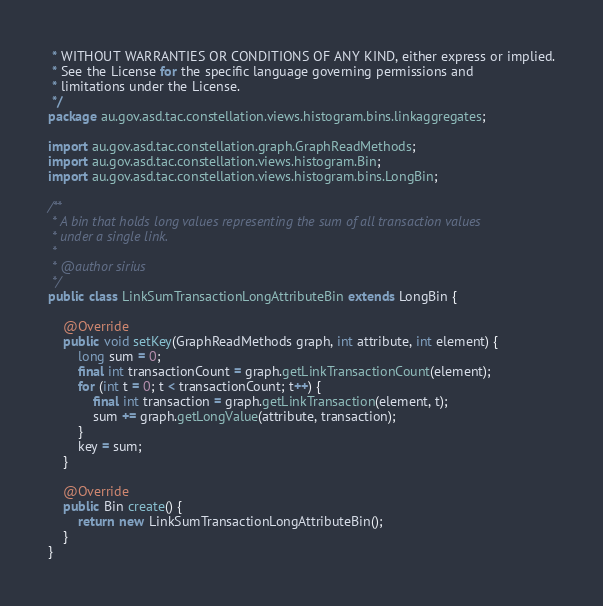<code> <loc_0><loc_0><loc_500><loc_500><_Java_> * WITHOUT WARRANTIES OR CONDITIONS OF ANY KIND, either express or implied.
 * See the License for the specific language governing permissions and
 * limitations under the License.
 */
package au.gov.asd.tac.constellation.views.histogram.bins.linkaggregates;

import au.gov.asd.tac.constellation.graph.GraphReadMethods;
import au.gov.asd.tac.constellation.views.histogram.Bin;
import au.gov.asd.tac.constellation.views.histogram.bins.LongBin;

/**
 * A bin that holds long values representing the sum of all transaction values
 * under a single link.
 *
 * @author sirius
 */
public class LinkSumTransactionLongAttributeBin extends LongBin {

    @Override
    public void setKey(GraphReadMethods graph, int attribute, int element) {
        long sum = 0;
        final int transactionCount = graph.getLinkTransactionCount(element);
        for (int t = 0; t < transactionCount; t++) {
            final int transaction = graph.getLinkTransaction(element, t);
            sum += graph.getLongValue(attribute, transaction);
        }
        key = sum;
    }

    @Override
    public Bin create() {
        return new LinkSumTransactionLongAttributeBin();
    }
}
</code> 